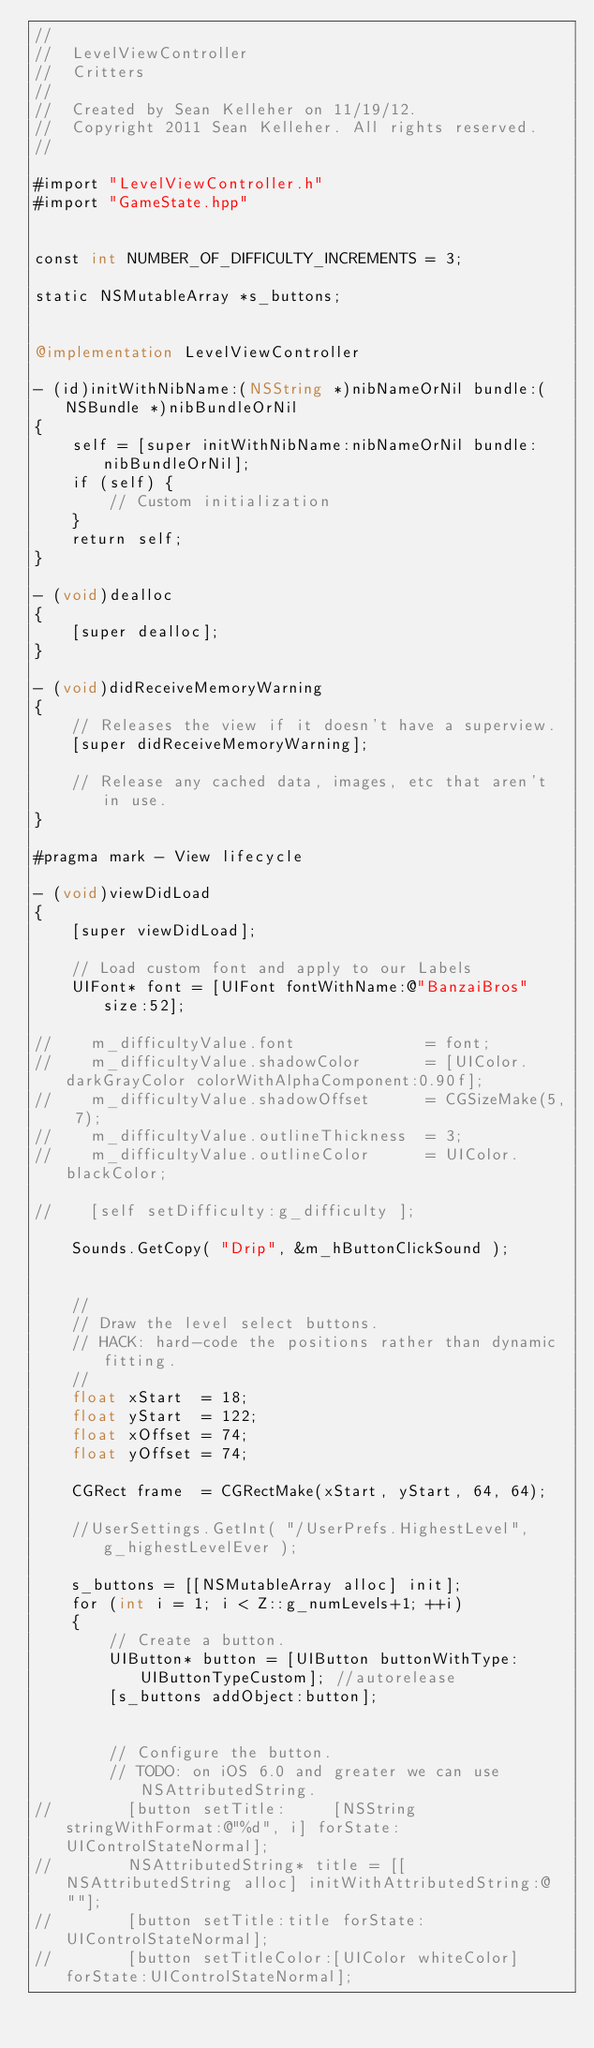Convert code to text. <code><loc_0><loc_0><loc_500><loc_500><_ObjectiveC_>//
//  LevelViewController
//  Critters
//
//  Created by Sean Kelleher on 11/19/12.
//  Copyright 2011 Sean Kelleher. All rights reserved.
//

#import "LevelViewController.h"
#import "GameState.hpp"


const int NUMBER_OF_DIFFICULTY_INCREMENTS = 3;

static NSMutableArray *s_buttons;


@implementation LevelViewController

- (id)initWithNibName:(NSString *)nibNameOrNil bundle:(NSBundle *)nibBundleOrNil
{
    self = [super initWithNibName:nibNameOrNil bundle:nibBundleOrNil];
    if (self) {
        // Custom initialization
    }
    return self;
}

- (void)dealloc
{
    [super dealloc];
}

- (void)didReceiveMemoryWarning
{
    // Releases the view if it doesn't have a superview.
    [super didReceiveMemoryWarning];
    
    // Release any cached data, images, etc that aren't in use.
}

#pragma mark - View lifecycle

- (void)viewDidLoad
{
    [super viewDidLoad];

    // Load custom font and apply to our Labels
    UIFont* font = [UIFont fontWithName:@"BanzaiBros" size:52];

//    m_difficultyValue.font              = font;
//    m_difficultyValue.shadowColor       = [UIColor.darkGrayColor colorWithAlphaComponent:0.90f];
//    m_difficultyValue.shadowOffset      = CGSizeMake(5, 7);
//    m_difficultyValue.outlineThickness  = 3;
//    m_difficultyValue.outlineColor      = UIColor.blackColor;

//    [self setDifficulty:g_difficulty ];

    Sounds.GetCopy( "Drip", &m_hButtonClickSound );
    
    
    //
    // Draw the level select buttons.
    // HACK: hard-code the positions rather than dynamic fitting.
    //
    float xStart  = 18;
    float yStart  = 122;
    float xOffset = 74;
    float yOffset = 74;

    CGRect frame  = CGRectMake(xStart, yStart, 64, 64);

    //UserSettings.GetInt( "/UserPrefs.HighestLevel", g_highestLevelEver );
    
    s_buttons = [[NSMutableArray alloc] init];
    for (int i = 1; i < Z::g_numLevels+1; ++i)
    {
        // Create a button.
        UIButton* button = [UIButton buttonWithType:UIButtonTypeCustom]; //autorelease
        [s_buttons addObject:button];


        // Configure the button.
        // TODO: on iOS 6.0 and greater we can use NSAttributedString.
//        [button setTitle:     [NSString stringWithFormat:@"%d", i] forState:UIControlStateNormal];
//        NSAttributedString* title = [[NSAttributedString alloc] initWithAttributedString:@""];
//        [button setTitle:title forState:UIControlStateNormal];
//        [button setTitleColor:[UIColor whiteColor] forState:UIControlStateNormal];
</code> 